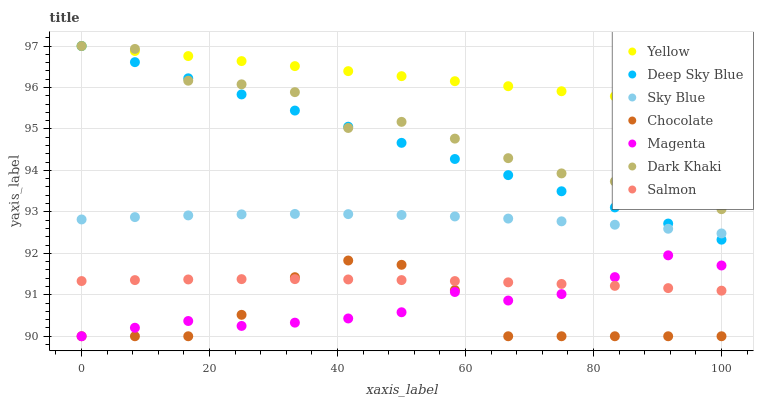Does Chocolate have the minimum area under the curve?
Answer yes or no. Yes. Does Yellow have the maximum area under the curve?
Answer yes or no. Yes. Does Yellow have the minimum area under the curve?
Answer yes or no. No. Does Chocolate have the maximum area under the curve?
Answer yes or no. No. Is Deep Sky Blue the smoothest?
Answer yes or no. Yes. Is Dark Khaki the roughest?
Answer yes or no. Yes. Is Yellow the smoothest?
Answer yes or no. No. Is Yellow the roughest?
Answer yes or no. No. Does Chocolate have the lowest value?
Answer yes or no. Yes. Does Yellow have the lowest value?
Answer yes or no. No. Does Deep Sky Blue have the highest value?
Answer yes or no. Yes. Does Chocolate have the highest value?
Answer yes or no. No. Is Magenta less than Deep Sky Blue?
Answer yes or no. Yes. Is Dark Khaki greater than Chocolate?
Answer yes or no. Yes. Does Dark Khaki intersect Deep Sky Blue?
Answer yes or no. Yes. Is Dark Khaki less than Deep Sky Blue?
Answer yes or no. No. Is Dark Khaki greater than Deep Sky Blue?
Answer yes or no. No. Does Magenta intersect Deep Sky Blue?
Answer yes or no. No. 